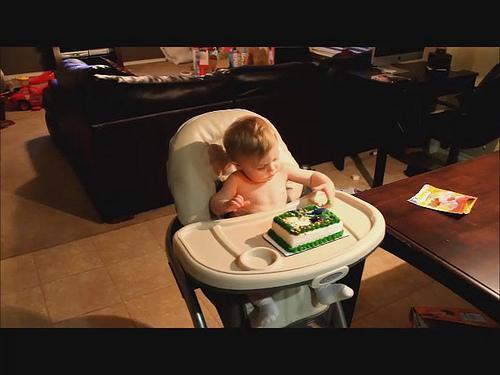How many kids are in the photo?
Give a very brief answer. 1. 